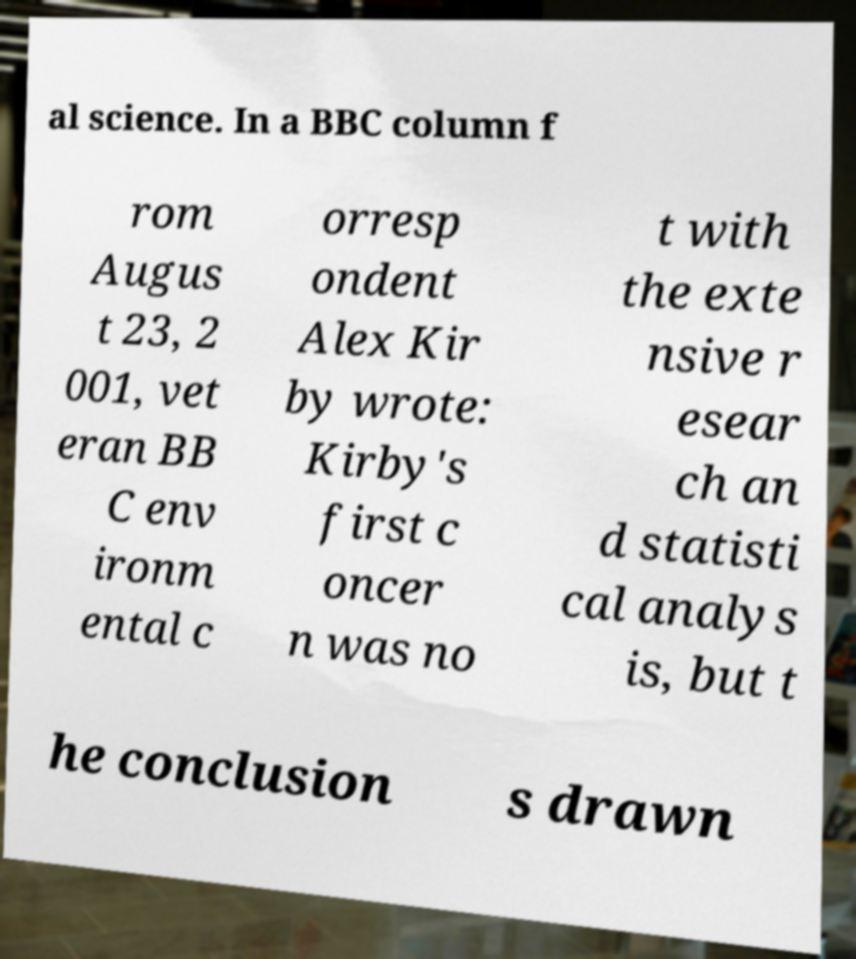Can you read and provide the text displayed in the image?This photo seems to have some interesting text. Can you extract and type it out for me? al science. In a BBC column f rom Augus t 23, 2 001, vet eran BB C env ironm ental c orresp ondent Alex Kir by wrote: Kirby's first c oncer n was no t with the exte nsive r esear ch an d statisti cal analys is, but t he conclusion s drawn 